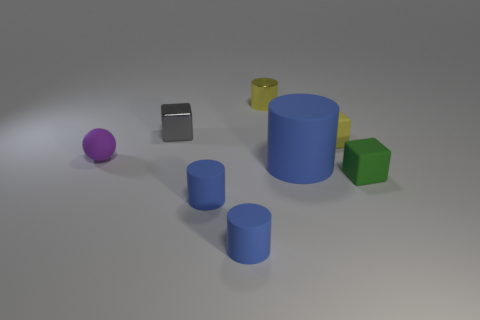What number of yellow objects have the same material as the sphere?
Give a very brief answer. 1. There is a thing that is the same color as the metal cylinder; what shape is it?
Ensure brevity in your answer.  Cube. What is the size of the shiny thing in front of the small yellow object that is behind the small yellow block?
Give a very brief answer. Small. There is a metal thing in front of the shiny cylinder; does it have the same shape as the tiny matte thing behind the purple ball?
Make the answer very short. Yes. Is the number of purple matte things that are on the right side of the gray cube the same as the number of tiny purple cylinders?
Give a very brief answer. Yes. What color is the other large thing that is the same shape as the yellow metallic thing?
Give a very brief answer. Blue. Is the material of the small cylinder behind the big blue cylinder the same as the green object?
Provide a succinct answer. No. How many tiny objects are metal cubes or yellow rubber blocks?
Provide a succinct answer. 2. The shiny cube is what size?
Your response must be concise. Small. Is the size of the shiny cylinder the same as the thing on the left side of the tiny gray object?
Make the answer very short. Yes. 